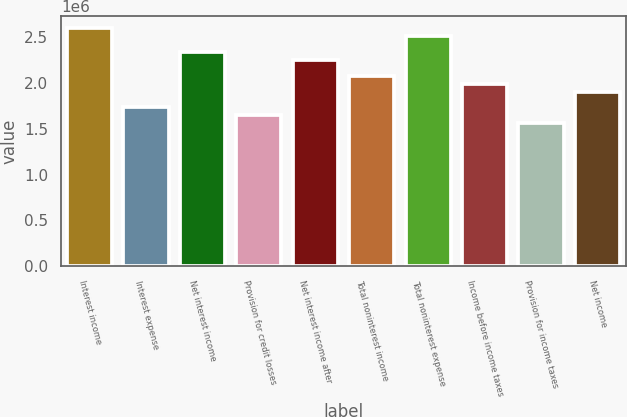Convert chart. <chart><loc_0><loc_0><loc_500><loc_500><bar_chart><fcel>Interest income<fcel>Interest expense<fcel>Net interest income<fcel>Provision for credit losses<fcel>Net interest income after<fcel>Total noninterest income<fcel>Total noninterest expense<fcel>Income before income taxes<fcel>Provision for income taxes<fcel>Net income<nl><fcel>2.60171e+06<fcel>1.73447e+06<fcel>2.34154e+06<fcel>1.64775e+06<fcel>2.25482e+06<fcel>2.08137e+06<fcel>2.51499e+06<fcel>1.99465e+06<fcel>1.56103e+06<fcel>1.90792e+06<nl></chart> 